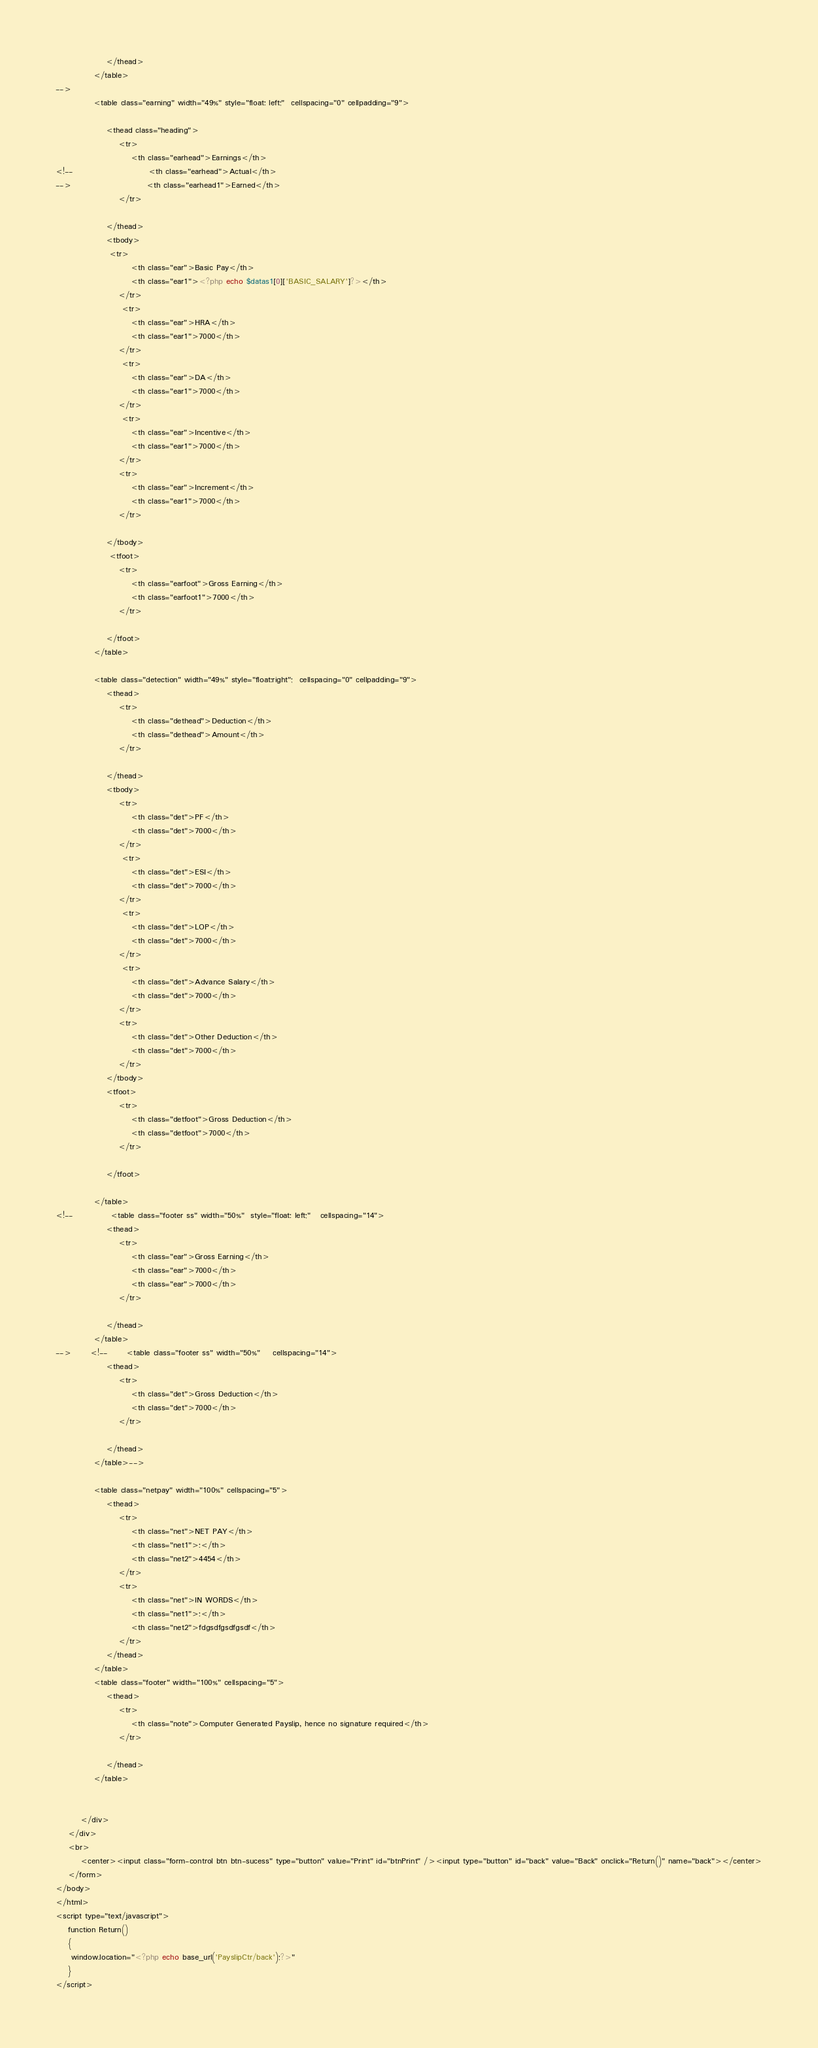Convert code to text. <code><loc_0><loc_0><loc_500><loc_500><_PHP_>
                </thead>
            </table>
-->
            <table class="earning" width="49%" style="float: left;"  cellspacing="0" cellpadding="9">
                
                <thead class="heading">
                    <tr>
                        <th class="earhead">Earnings</th>
<!--                        <th class="earhead">Actual</th>
-->                        <th class="earhead1">Earned</th>
                    </tr>

                </thead>
                <tbody>
                 <tr>
                        <th class="ear">Basic Pay</th>
                        <th class="ear1"><?php echo $datas1[0]['BASIC_SALARY']?></th>
                    </tr>
                     <tr>
                        <th class="ear">HRA</th>
                        <th class="ear1">7000</th>
                    </tr>
                     <tr>
                        <th class="ear">DA</th>
                        <th class="ear1">7000</th>
                    </tr>
                     <tr>
                        <th class="ear">Incentive</th>
                        <th class="ear1">7000</th>
                    </tr>
                    <tr>
                        <th class="ear">Increment</th>
                        <th class="ear1">7000</th>
                    </tr>                    

                </tbody>
                 <tfoot>
                    <tr>
                        <th class="earfoot">Gross Earning</th>
                        <th class="earfoot1">7000</th>
                    </tr>

                </tfoot>
            </table>

            <table class="detection" width="49%" style="float:right";  cellspacing="0" cellpadding="9">
                <thead>
                    <tr>
                        <th class="dethead">Deduction</th>
                        <th class="dethead">Amount</th>
                    </tr>

                </thead>
                <tbody>
                    <tr>
                        <th class="det">PF</th>
                        <th class="det">7000</th>
                    </tr>
                     <tr>
                        <th class="det">ESI</th>
                        <th class="det">7000</th>
                    </tr>
                     <tr>
                        <th class="det">LOP</th>
                        <th class="det">7000</th>
                    </tr>
                     <tr>
                        <th class="det">Advance Salary</th>
                        <th class="det">7000</th>
                    </tr>
                    <tr>
                        <th class="det">Other Deduction</th>
                        <th class="det">7000</th>
                    </tr>
                </tbody>
                <tfoot>
                    <tr>
                        <th class="detfoot">Gross Deduction</th>
                        <th class="detfoot">7000</th>
                    </tr>

                </tfoot>

            </table>
<!--            <table class="footer ss" width="50%"  style="float: left;"   cellspacing="14">
                <thead>
                    <tr>
                        <th class="ear">Gross Earning</th>
                        <th class="ear">7000</th>
                        <th class="ear">7000</th>
                    </tr>

                </thead>
            </table>
-->      <!--      <table class="footer ss" width="50%"    cellspacing="14">
                <thead>
                    <tr>
                        <th class="det">Gross Deduction</th>
                        <th class="det">7000</th>
                    </tr>

                </thead>
            </table>-->

            <table class="netpay" width="100%" cellspacing="5">
                <thead>
                    <tr>
                        <th class="net">NET PAY</th>
                        <th class="net1">:</th>
                        <th class="net2">4454</th>
                    </tr>
                    <tr>
                        <th class="net">IN WORDS</th>
                        <th class="net1">:</th>
                        <th class="net2">fdgsdfgsdfgsdf</th>
                    </tr>
                </thead>
            </table>
            <table class="footer" width="100%" cellspacing="5">
                <thead>
                    <tr>
                        <th class="note">Computer Generated Payslip, hence no signature required</th>
                    </tr>

                </thead>
            </table>


        </div>
    </div>
    <br>
        <center><input class="form-control btn btn-sucess" type="button" value="Print" id="btnPrint" /><input type="button" id="back" value="Back" onclick="Return()" name="back"></center>
    </form>
</body>
</html>
<script type="text/javascript">
    function Return()
    {
     window.location="<?php echo base_url('PayslipCtr/back');?>"   
    }
</script></code> 